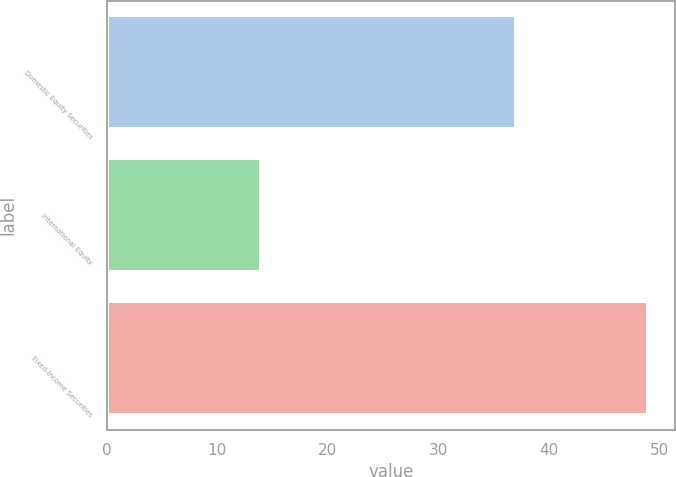Convert chart to OTSL. <chart><loc_0><loc_0><loc_500><loc_500><bar_chart><fcel>Domestic Equity Securities<fcel>International Equity<fcel>Fixed-Income Securities<nl><fcel>37<fcel>14<fcel>49<nl></chart> 